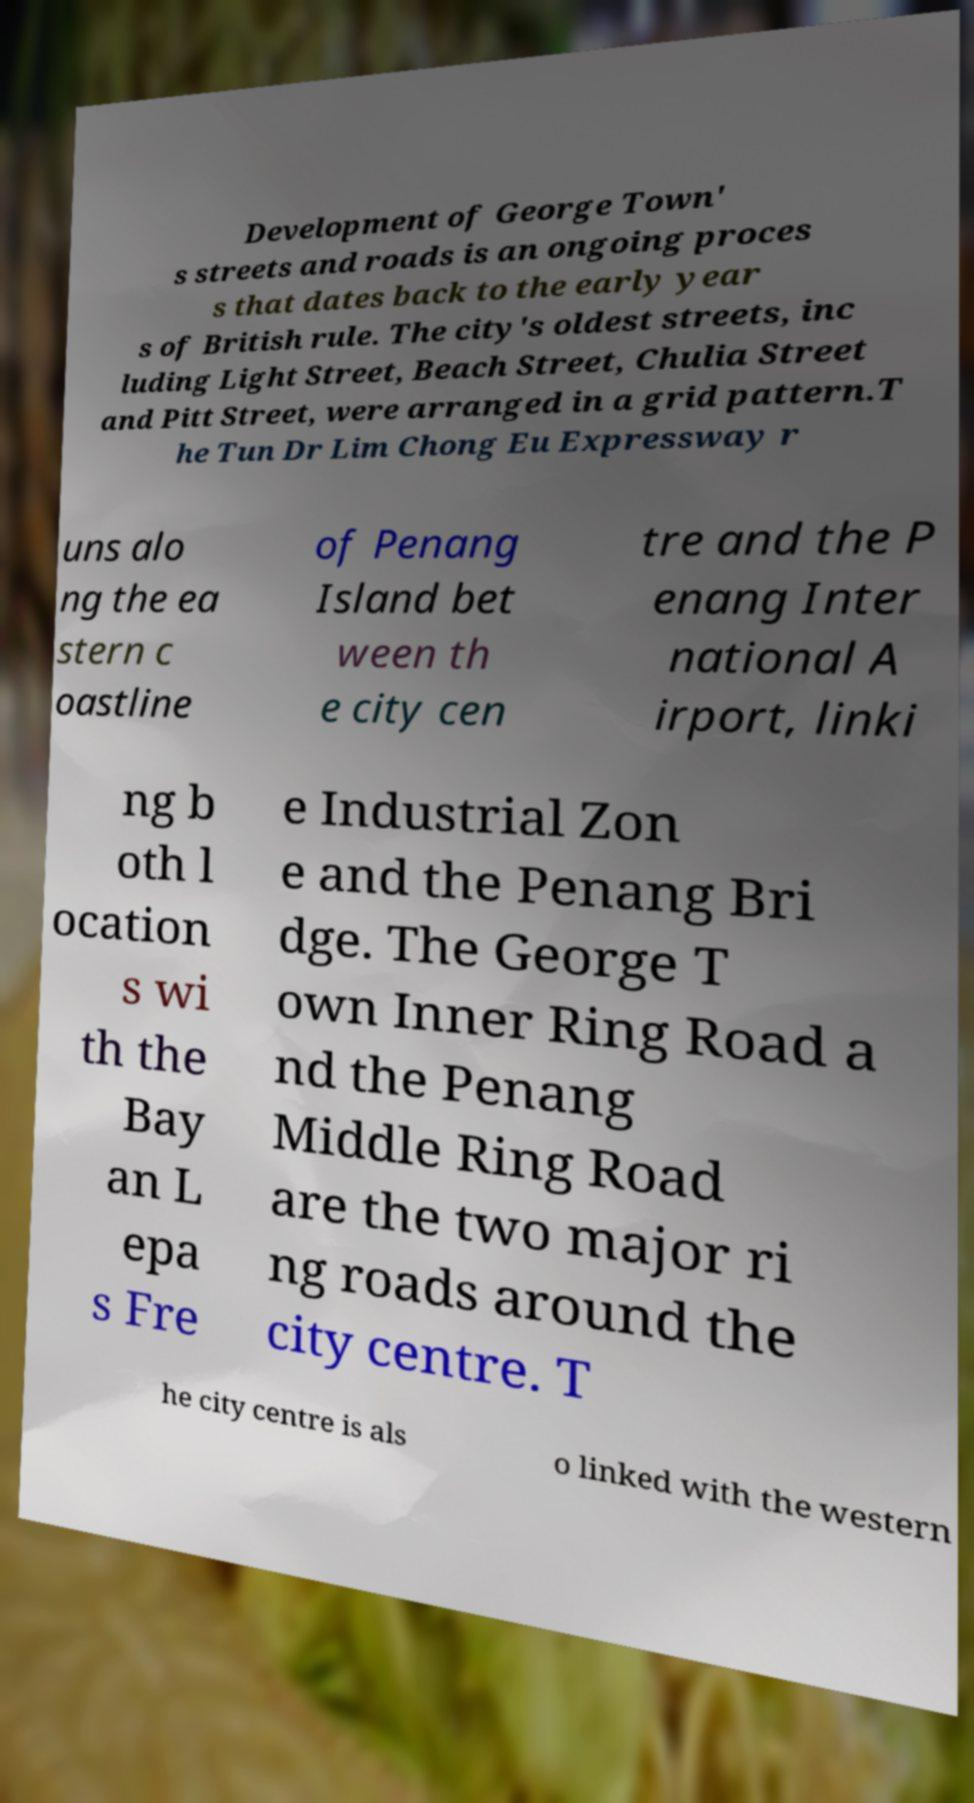Could you extract and type out the text from this image? Development of George Town' s streets and roads is an ongoing proces s that dates back to the early year s of British rule. The city's oldest streets, inc luding Light Street, Beach Street, Chulia Street and Pitt Street, were arranged in a grid pattern.T he Tun Dr Lim Chong Eu Expressway r uns alo ng the ea stern c oastline of Penang Island bet ween th e city cen tre and the P enang Inter national A irport, linki ng b oth l ocation s wi th the Bay an L epa s Fre e Industrial Zon e and the Penang Bri dge. The George T own Inner Ring Road a nd the Penang Middle Ring Road are the two major ri ng roads around the city centre. T he city centre is als o linked with the western 